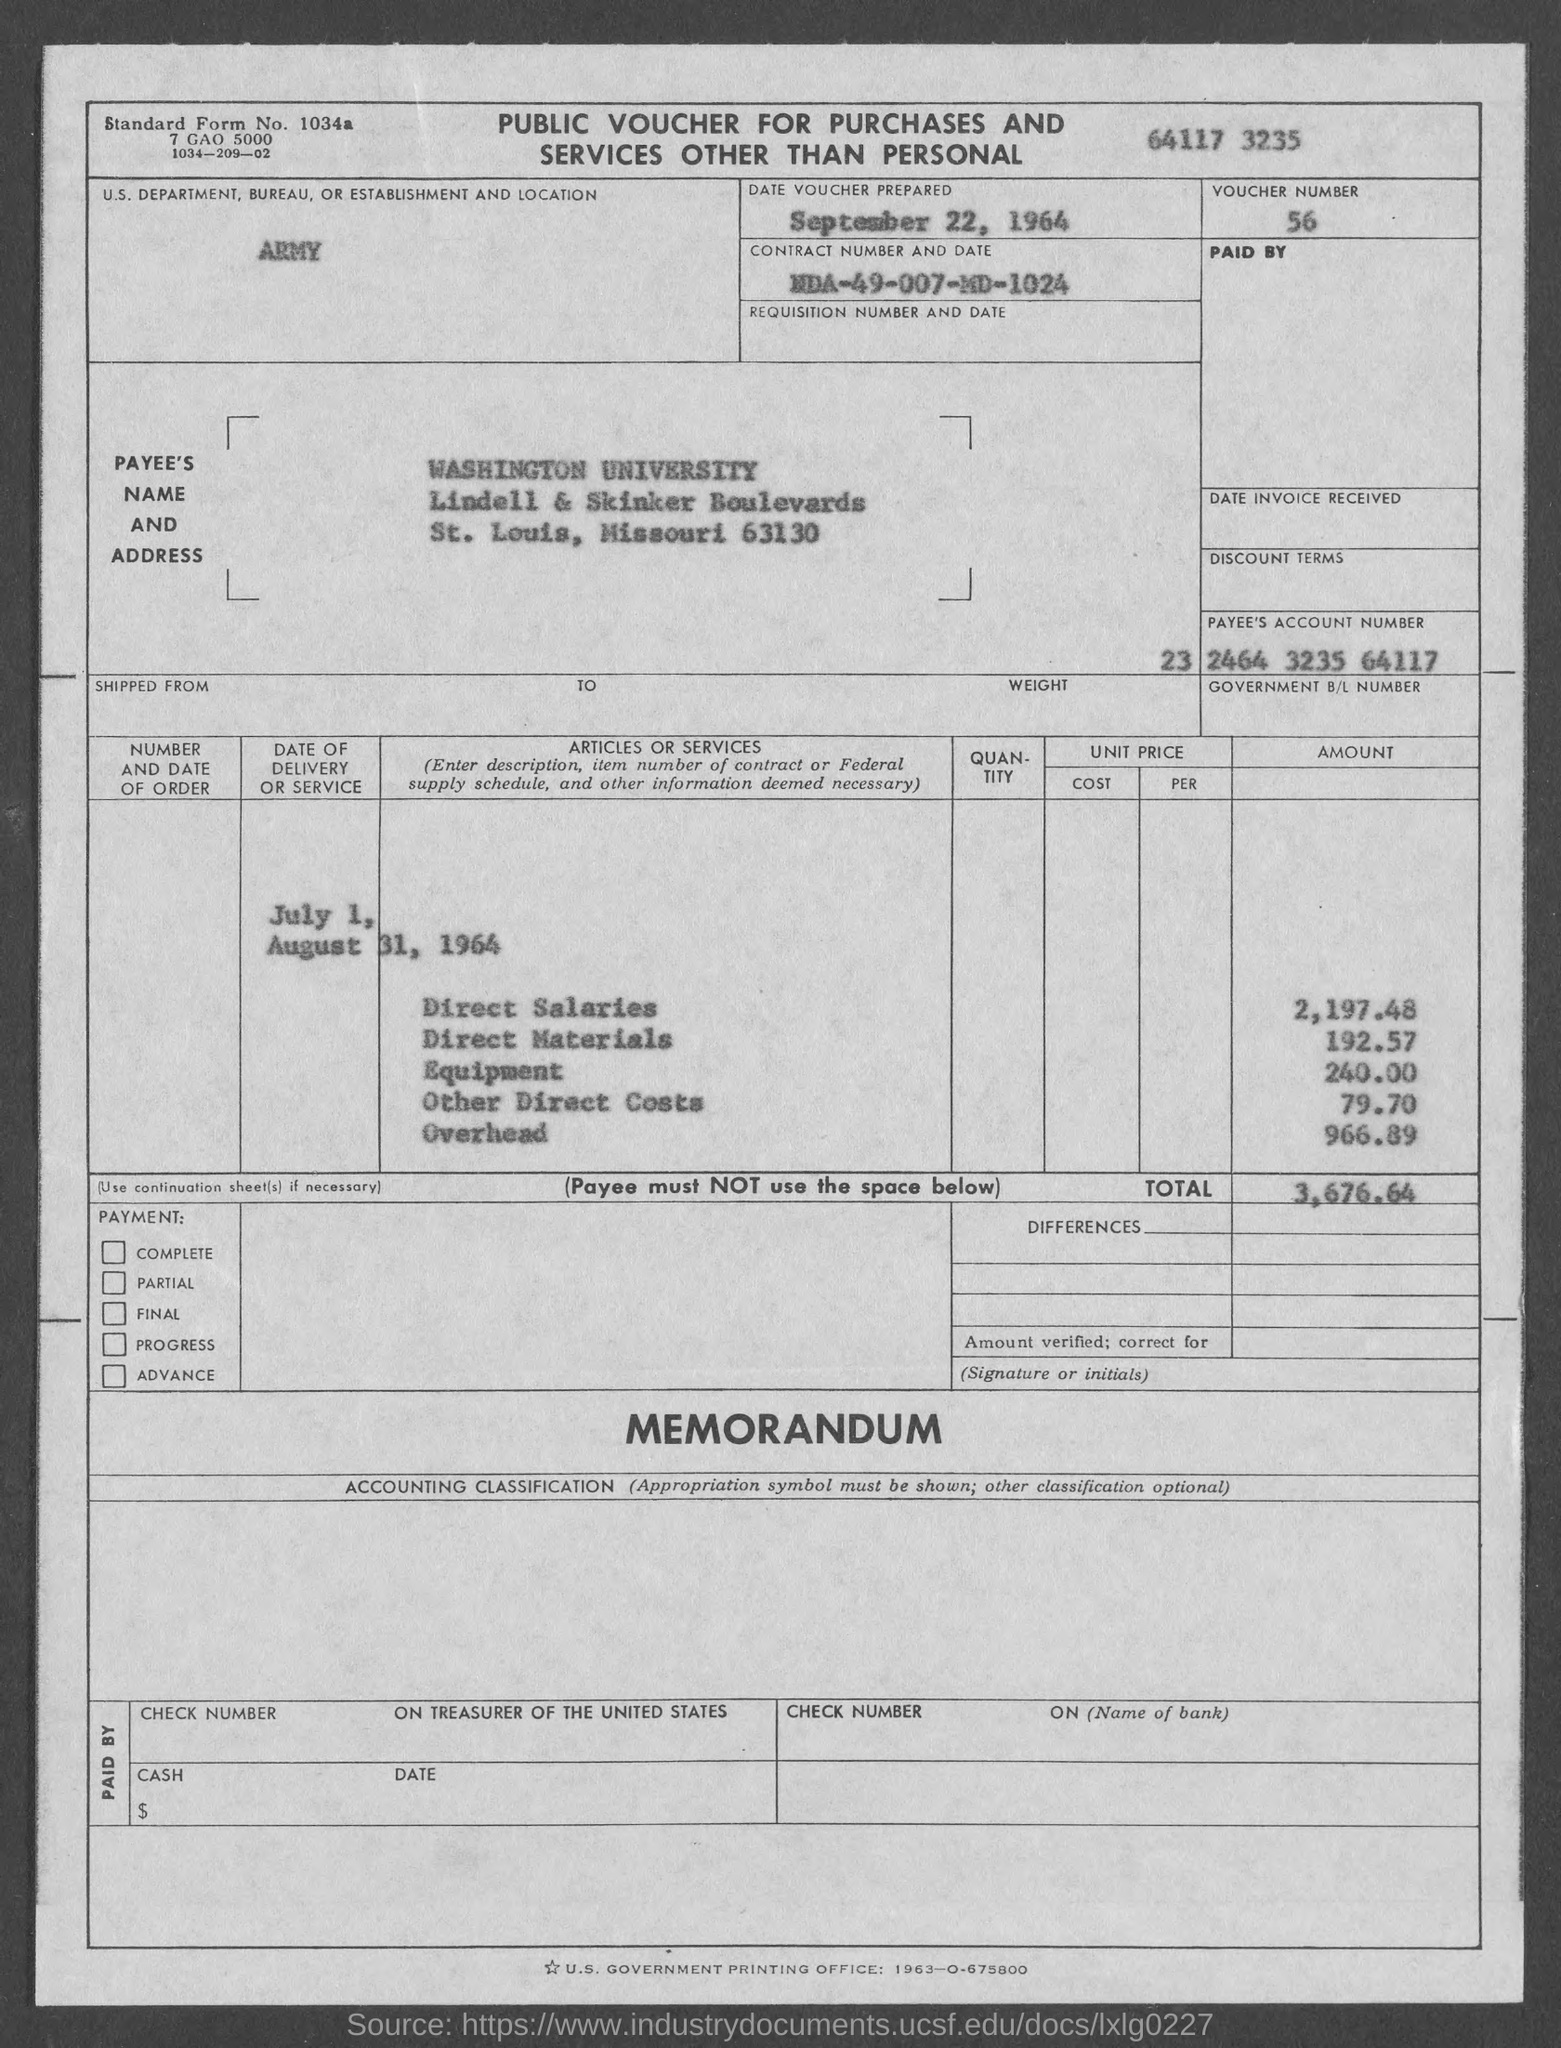Point out several critical features in this image. The voucher number is 56. The overhead amount is 966.89. The total amount is 3,676.64. The payee's account number is 23 2464 3235 64117. The date of the voucher is September 22, 1964. 